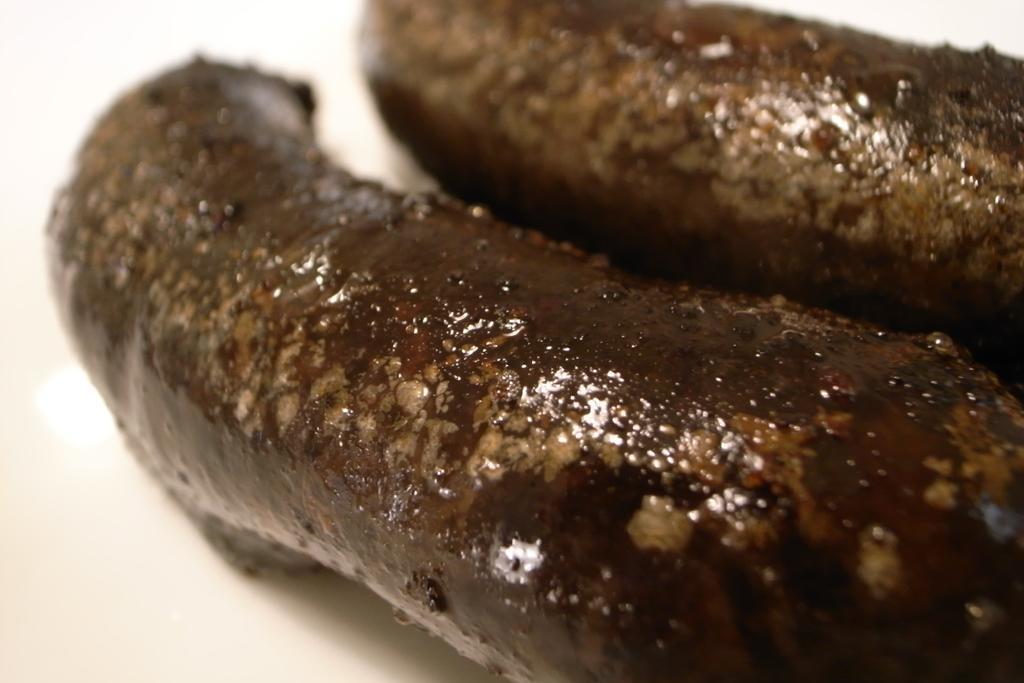Could you give a brief overview of what you see in this image? In this image I can see the white colored surface and on the white colored surface I can see two objects which are brown and cream in color. 